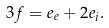<formula> <loc_0><loc_0><loc_500><loc_500>3 f = e _ { e } + 2 e _ { i } .</formula> 